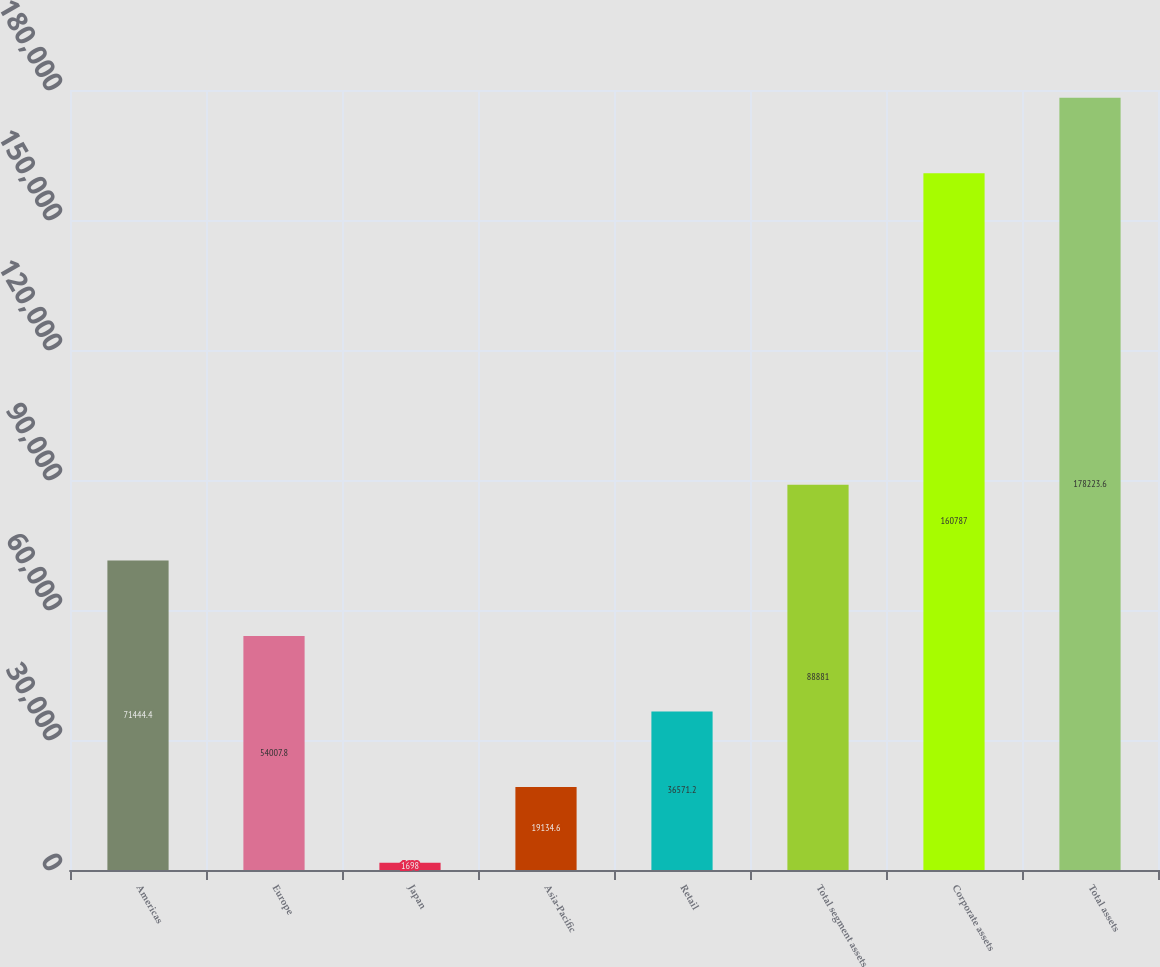Convert chart. <chart><loc_0><loc_0><loc_500><loc_500><bar_chart><fcel>Americas<fcel>Europe<fcel>Japan<fcel>Asia-Pacific<fcel>Retail<fcel>Total segment assets<fcel>Corporate assets<fcel>Total assets<nl><fcel>71444.4<fcel>54007.8<fcel>1698<fcel>19134.6<fcel>36571.2<fcel>88881<fcel>160787<fcel>178224<nl></chart> 